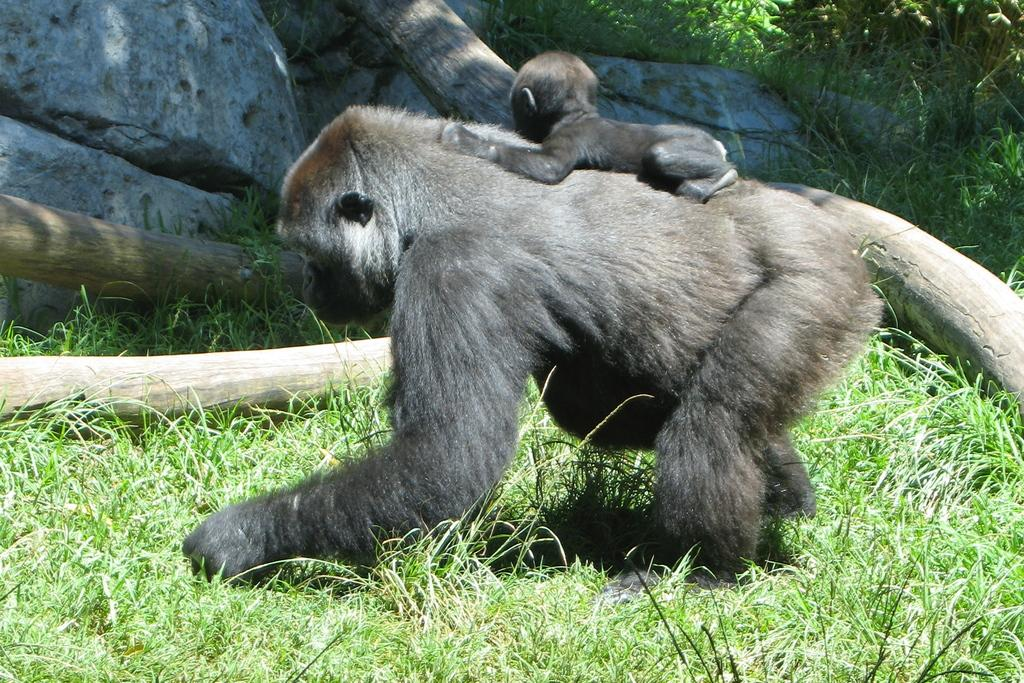What type of animals are in the image? There are monkeys in the image. What type of terrain is visible in the image? There is grass and rocks in the image. What type of loaf can be seen in the mouth of the monkey in the image? There is no loaf present in the image, and the monkeys do not have mouths visible. 